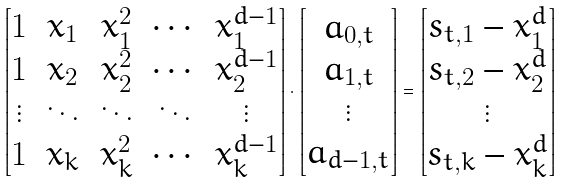Convert formula to latex. <formula><loc_0><loc_0><loc_500><loc_500>\begin{bmatrix} 1 & x _ { 1 } & x _ { 1 } ^ { 2 } & \cdots & x _ { 1 } ^ { d - 1 } \\ 1 & x _ { 2 } & x _ { 2 } ^ { 2 } & \cdots & x _ { 2 } ^ { d - 1 } \\ \vdots & \ddots & \ddots & \ddots & \vdots \\ 1 & x _ { k } & x _ { k } ^ { 2 } & \cdots & x _ { k } ^ { d - 1 } \end{bmatrix} \cdot \begin{bmatrix} a _ { 0 , t } \\ a _ { 1 , t } \\ \vdots \\ a _ { d - 1 , t } \end{bmatrix} = \begin{bmatrix} s _ { t , 1 } - x _ { 1 } ^ { d } \\ s _ { t , 2 } - x _ { 2 } ^ { d } \\ \vdots \\ s _ { t , k } - x _ { k } ^ { d } \end{bmatrix}</formula> 